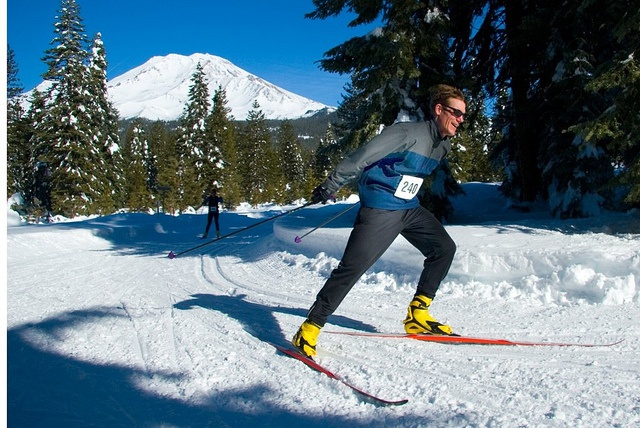Describe the objects in this image and their specific colors. I can see people in white, black, gray, blue, and navy tones, skis in white, lightgray, gray, darkgray, and blue tones, people in white, black, navy, blue, and gray tones, and skis in darkblue, white, black, and navy tones in this image. 